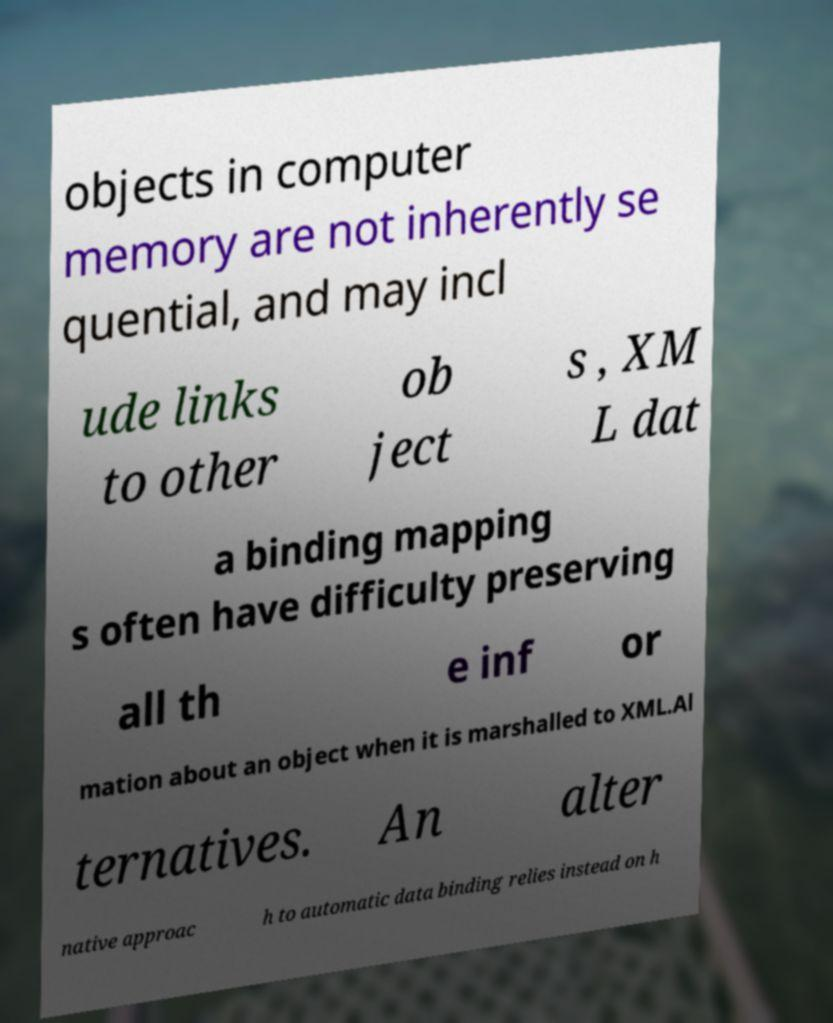Could you extract and type out the text from this image? objects in computer memory are not inherently se quential, and may incl ude links to other ob ject s , XM L dat a binding mapping s often have difficulty preserving all th e inf or mation about an object when it is marshalled to XML.Al ternatives. An alter native approac h to automatic data binding relies instead on h 